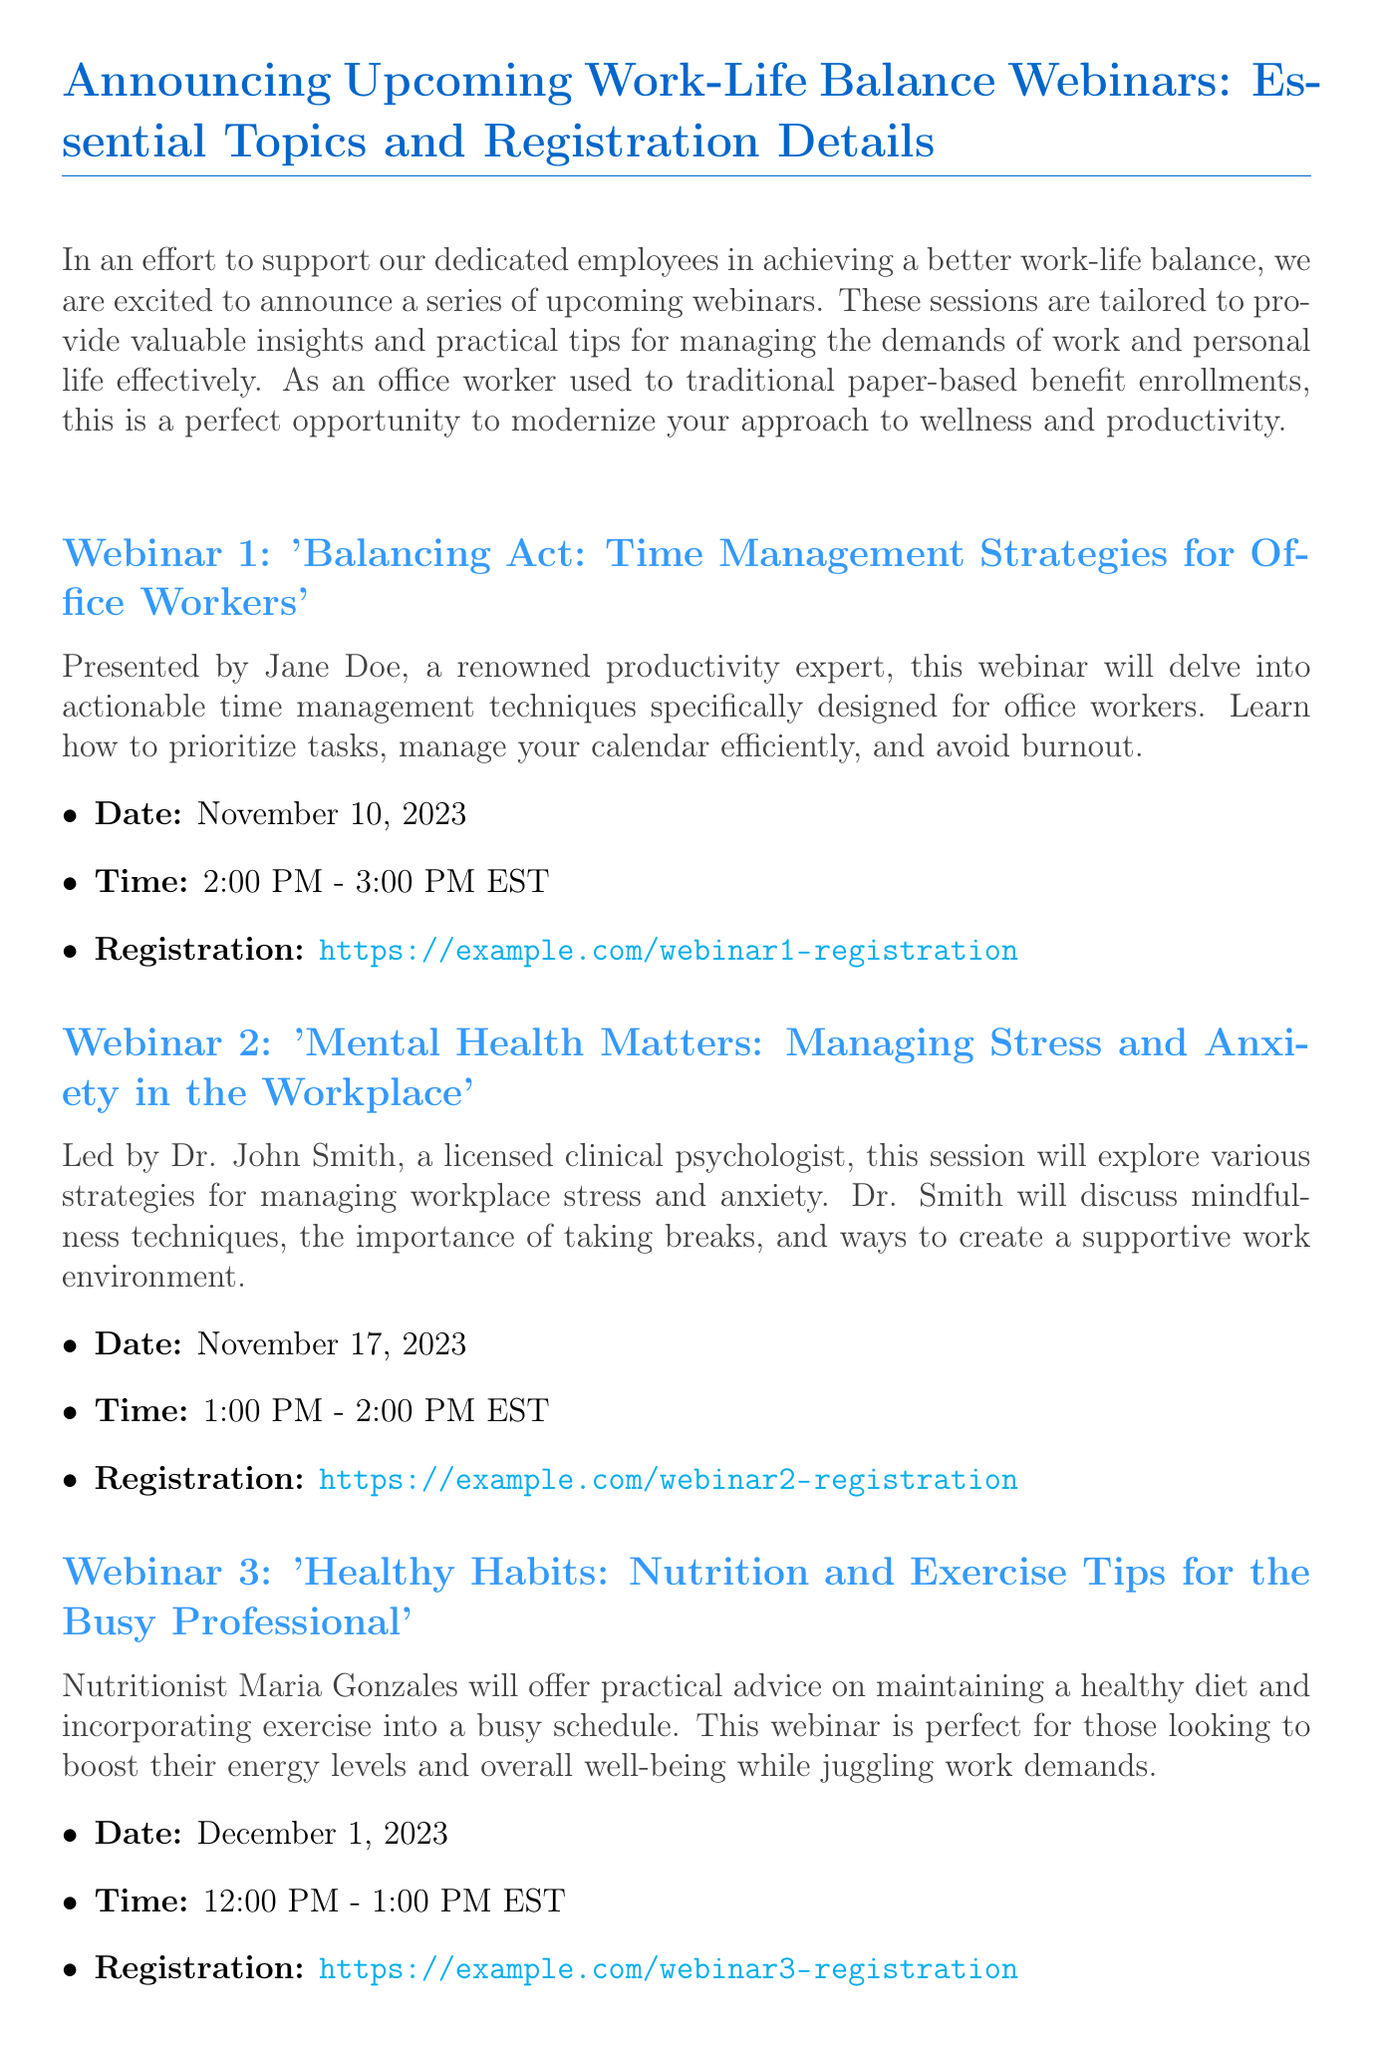What is the title of the first webinar? The title is explicitly stated as the first webinar in the document.
Answer: Balancing Act: Time Management Strategies for Office Workers Who is the presenter of the second webinar? The presenter's name is mentioned in the description of the second webinar.
Answer: Dr. John Smith When is the third webinar scheduled? The date for the third webinar is specifically listed in the document's description.
Answer: December 1, 2023 What time does the first webinar start? The start time is provided in the details for the first webinar.
Answer: 2:00 PM What is the main topic of the second webinar? This information is summarized in the introductory sentence of the second webinar description.
Answer: Managing Stress and Anxiety in the Workplace How many webinars are mentioned in the document? The total count of webinars can be deduced from the list presented.
Answer: Three What is the registration link for the first webinar? This link is cited directly after the first webinar details.
Answer: https://example.com/webinar1-registration Who should be contacted for questions regarding the webinars? The document specifies a contact point for inquiries.
Answer: HR department at hr@example.com 